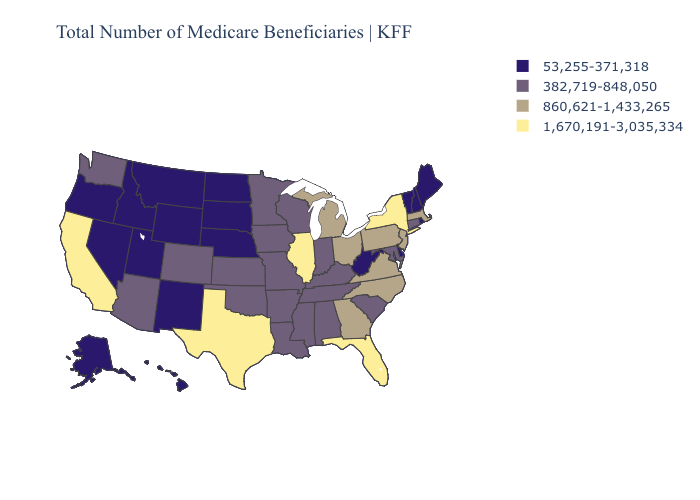Name the states that have a value in the range 1,670,191-3,035,334?
Quick response, please. California, Florida, Illinois, New York, Texas. Name the states that have a value in the range 1,670,191-3,035,334?
Short answer required. California, Florida, Illinois, New York, Texas. Does New York have the highest value in the Northeast?
Quick response, please. Yes. Does New York have a higher value than New Mexico?
Concise answer only. Yes. Which states have the lowest value in the MidWest?
Short answer required. Nebraska, North Dakota, South Dakota. Does Maine have a lower value than Utah?
Give a very brief answer. No. Does Maryland have a lower value than Idaho?
Write a very short answer. No. Which states have the lowest value in the West?
Short answer required. Alaska, Hawaii, Idaho, Montana, Nevada, New Mexico, Oregon, Utah, Wyoming. Which states have the highest value in the USA?
Be succinct. California, Florida, Illinois, New York, Texas. What is the value of Utah?
Give a very brief answer. 53,255-371,318. What is the value of North Carolina?
Short answer required. 860,621-1,433,265. Name the states that have a value in the range 382,719-848,050?
Short answer required. Alabama, Arizona, Arkansas, Colorado, Connecticut, Indiana, Iowa, Kansas, Kentucky, Louisiana, Maryland, Minnesota, Mississippi, Missouri, Oklahoma, South Carolina, Tennessee, Washington, Wisconsin. Does Iowa have a higher value than Vermont?
Short answer required. Yes. What is the lowest value in states that border Mississippi?
Give a very brief answer. 382,719-848,050. 